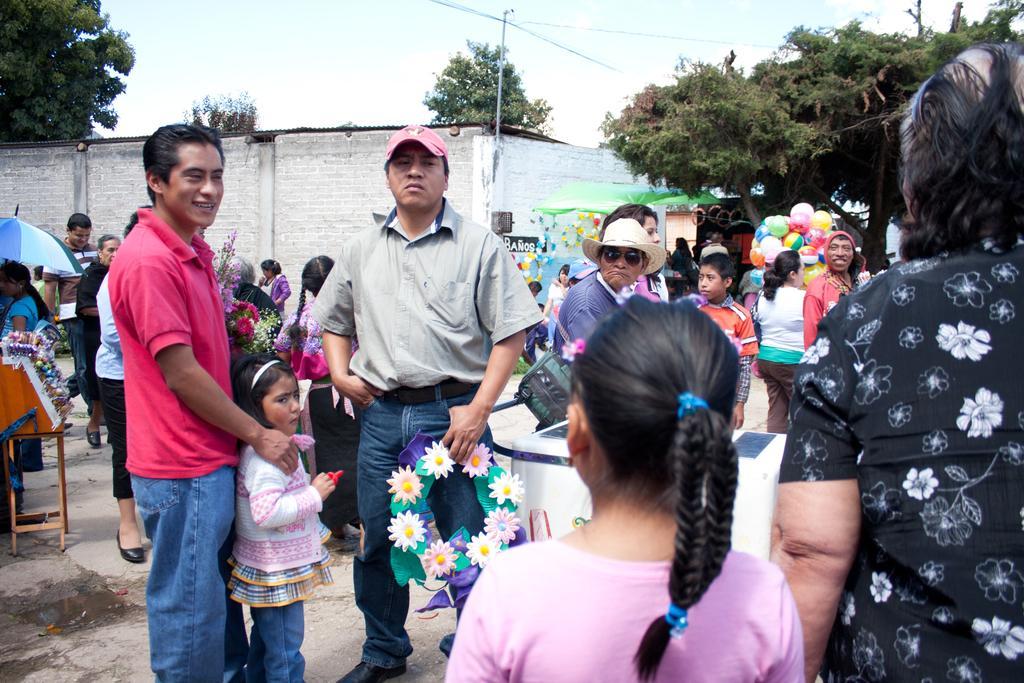Please provide a concise description of this image. In this image there are many people standing. To the left there are stalls. There are flower bouquets on a table. There is a person holding balloons. In the background there are trees, house and poles. At the top there is the sky. 